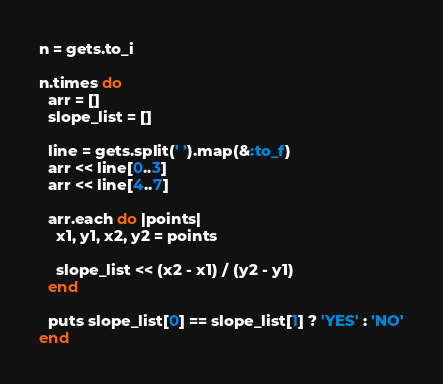<code> <loc_0><loc_0><loc_500><loc_500><_Ruby_>n = gets.to_i

n.times do
  arr = []
  slope_list = []

  line = gets.split(' ').map(&:to_f)
  arr << line[0..3]
  arr << line[4..7]

  arr.each do |points|
    x1, y1, x2, y2 = points

    slope_list << (x2 - x1) / (y2 - y1)
  end

  puts slope_list[0] == slope_list[1] ? 'YES' : 'NO'
end</code> 